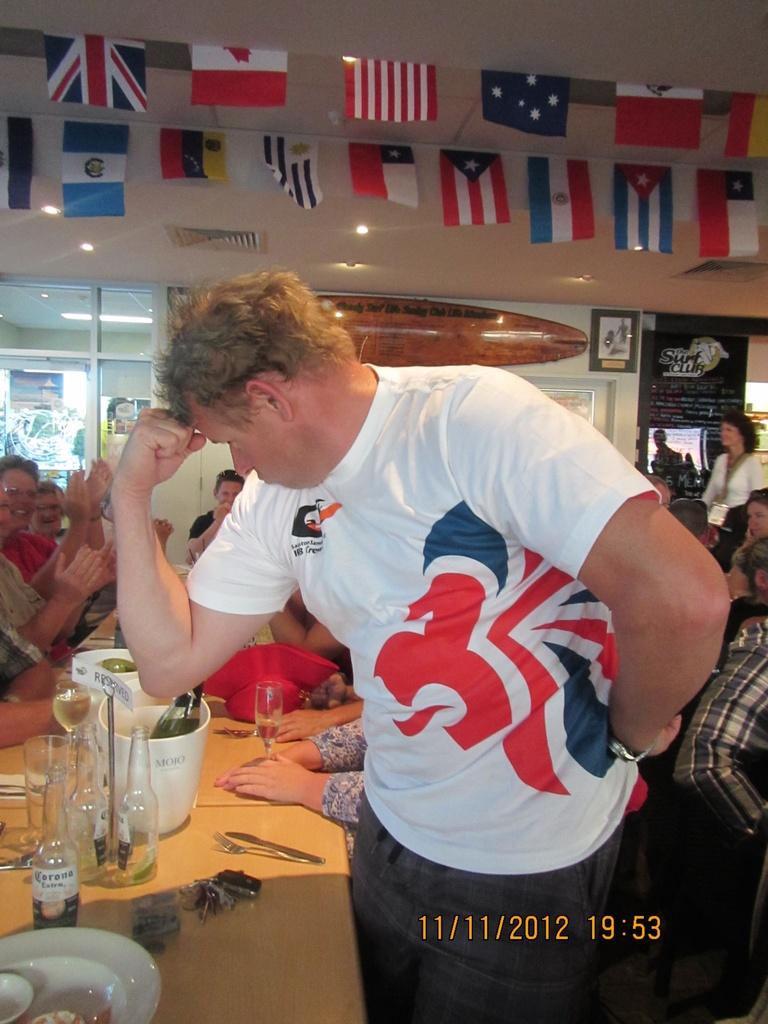What time was this photo taken?
Your response must be concise. 19:53. 